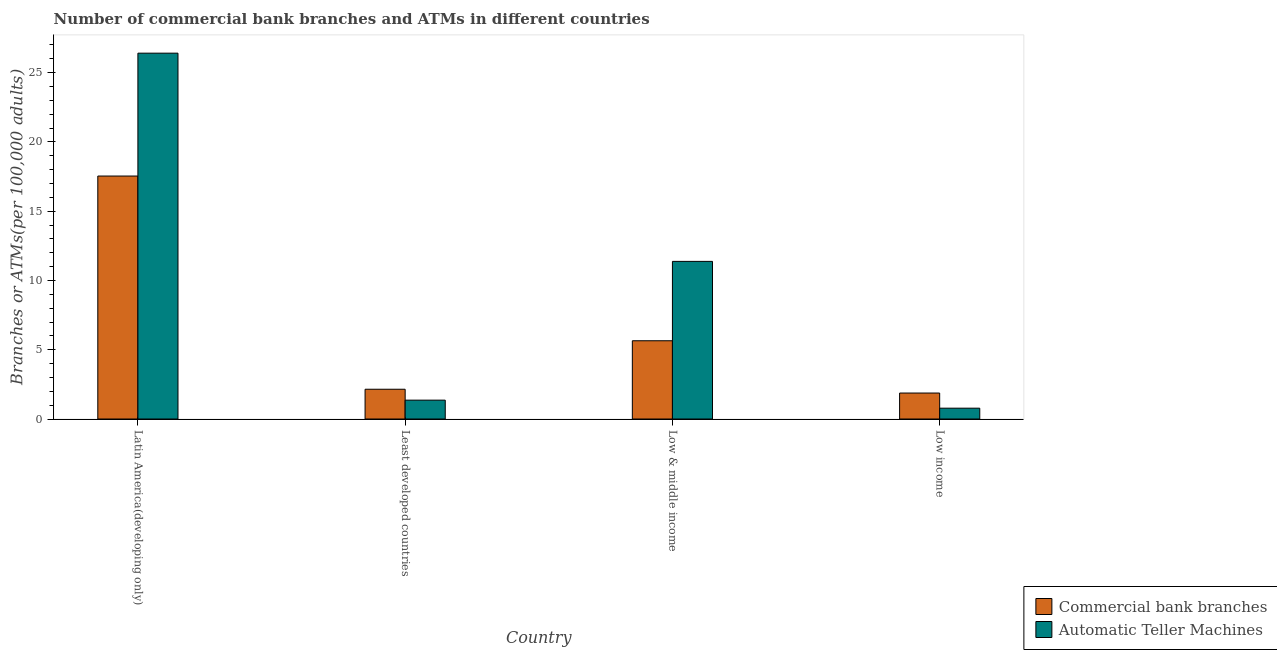How many groups of bars are there?
Offer a terse response. 4. Are the number of bars per tick equal to the number of legend labels?
Make the answer very short. Yes. How many bars are there on the 2nd tick from the left?
Offer a very short reply. 2. What is the label of the 4th group of bars from the left?
Keep it short and to the point. Low income. What is the number of commercal bank branches in Low & middle income?
Offer a very short reply. 5.65. Across all countries, what is the maximum number of atms?
Offer a terse response. 26.4. Across all countries, what is the minimum number of atms?
Keep it short and to the point. 0.78. In which country was the number of atms maximum?
Give a very brief answer. Latin America(developing only). What is the total number of commercal bank branches in the graph?
Your answer should be very brief. 27.21. What is the difference between the number of commercal bank branches in Latin America(developing only) and that in Low income?
Provide a short and direct response. 15.66. What is the difference between the number of atms in Low income and the number of commercal bank branches in Low & middle income?
Offer a very short reply. -4.87. What is the average number of atms per country?
Provide a succinct answer. 9.98. What is the difference between the number of atms and number of commercal bank branches in Latin America(developing only)?
Provide a short and direct response. 8.87. What is the ratio of the number of commercal bank branches in Latin America(developing only) to that in Low income?
Give a very brief answer. 9.35. What is the difference between the highest and the second highest number of atms?
Your answer should be compact. 15.03. What is the difference between the highest and the lowest number of commercal bank branches?
Offer a terse response. 15.66. In how many countries, is the number of atms greater than the average number of atms taken over all countries?
Your response must be concise. 2. Is the sum of the number of atms in Low & middle income and Low income greater than the maximum number of commercal bank branches across all countries?
Provide a short and direct response. No. What does the 2nd bar from the left in Low income represents?
Your response must be concise. Automatic Teller Machines. What does the 2nd bar from the right in Latin America(developing only) represents?
Your response must be concise. Commercial bank branches. Does the graph contain any zero values?
Provide a succinct answer. No. Does the graph contain grids?
Your answer should be very brief. No. Where does the legend appear in the graph?
Ensure brevity in your answer.  Bottom right. How are the legend labels stacked?
Ensure brevity in your answer.  Vertical. What is the title of the graph?
Offer a very short reply. Number of commercial bank branches and ATMs in different countries. Does "Girls" appear as one of the legend labels in the graph?
Make the answer very short. No. What is the label or title of the Y-axis?
Your answer should be compact. Branches or ATMs(per 100,0 adults). What is the Branches or ATMs(per 100,000 adults) of Commercial bank branches in Latin America(developing only)?
Your response must be concise. 17.53. What is the Branches or ATMs(per 100,000 adults) of Automatic Teller Machines in Latin America(developing only)?
Make the answer very short. 26.4. What is the Branches or ATMs(per 100,000 adults) of Commercial bank branches in Least developed countries?
Your answer should be compact. 2.15. What is the Branches or ATMs(per 100,000 adults) of Automatic Teller Machines in Least developed countries?
Your response must be concise. 1.36. What is the Branches or ATMs(per 100,000 adults) in Commercial bank branches in Low & middle income?
Provide a succinct answer. 5.65. What is the Branches or ATMs(per 100,000 adults) of Automatic Teller Machines in Low & middle income?
Offer a very short reply. 11.38. What is the Branches or ATMs(per 100,000 adults) in Commercial bank branches in Low income?
Your answer should be compact. 1.88. What is the Branches or ATMs(per 100,000 adults) of Automatic Teller Machines in Low income?
Your answer should be compact. 0.78. Across all countries, what is the maximum Branches or ATMs(per 100,000 adults) in Commercial bank branches?
Your answer should be compact. 17.53. Across all countries, what is the maximum Branches or ATMs(per 100,000 adults) of Automatic Teller Machines?
Offer a very short reply. 26.4. Across all countries, what is the minimum Branches or ATMs(per 100,000 adults) of Commercial bank branches?
Your answer should be compact. 1.88. Across all countries, what is the minimum Branches or ATMs(per 100,000 adults) of Automatic Teller Machines?
Your answer should be compact. 0.78. What is the total Branches or ATMs(per 100,000 adults) in Commercial bank branches in the graph?
Keep it short and to the point. 27.21. What is the total Branches or ATMs(per 100,000 adults) of Automatic Teller Machines in the graph?
Your answer should be very brief. 39.92. What is the difference between the Branches or ATMs(per 100,000 adults) of Commercial bank branches in Latin America(developing only) and that in Least developed countries?
Keep it short and to the point. 15.39. What is the difference between the Branches or ATMs(per 100,000 adults) of Automatic Teller Machines in Latin America(developing only) and that in Least developed countries?
Give a very brief answer. 25.04. What is the difference between the Branches or ATMs(per 100,000 adults) of Commercial bank branches in Latin America(developing only) and that in Low & middle income?
Make the answer very short. 11.89. What is the difference between the Branches or ATMs(per 100,000 adults) of Automatic Teller Machines in Latin America(developing only) and that in Low & middle income?
Give a very brief answer. 15.03. What is the difference between the Branches or ATMs(per 100,000 adults) of Commercial bank branches in Latin America(developing only) and that in Low income?
Provide a succinct answer. 15.66. What is the difference between the Branches or ATMs(per 100,000 adults) in Automatic Teller Machines in Latin America(developing only) and that in Low income?
Your answer should be very brief. 25.62. What is the difference between the Branches or ATMs(per 100,000 adults) of Commercial bank branches in Least developed countries and that in Low & middle income?
Offer a terse response. -3.5. What is the difference between the Branches or ATMs(per 100,000 adults) of Automatic Teller Machines in Least developed countries and that in Low & middle income?
Offer a very short reply. -10.01. What is the difference between the Branches or ATMs(per 100,000 adults) in Commercial bank branches in Least developed countries and that in Low income?
Your response must be concise. 0.27. What is the difference between the Branches or ATMs(per 100,000 adults) of Automatic Teller Machines in Least developed countries and that in Low income?
Your response must be concise. 0.58. What is the difference between the Branches or ATMs(per 100,000 adults) in Commercial bank branches in Low & middle income and that in Low income?
Offer a terse response. 3.77. What is the difference between the Branches or ATMs(per 100,000 adults) of Automatic Teller Machines in Low & middle income and that in Low income?
Your response must be concise. 10.59. What is the difference between the Branches or ATMs(per 100,000 adults) in Commercial bank branches in Latin America(developing only) and the Branches or ATMs(per 100,000 adults) in Automatic Teller Machines in Least developed countries?
Your answer should be very brief. 16.17. What is the difference between the Branches or ATMs(per 100,000 adults) of Commercial bank branches in Latin America(developing only) and the Branches or ATMs(per 100,000 adults) of Automatic Teller Machines in Low & middle income?
Offer a very short reply. 6.16. What is the difference between the Branches or ATMs(per 100,000 adults) of Commercial bank branches in Latin America(developing only) and the Branches or ATMs(per 100,000 adults) of Automatic Teller Machines in Low income?
Offer a very short reply. 16.75. What is the difference between the Branches or ATMs(per 100,000 adults) in Commercial bank branches in Least developed countries and the Branches or ATMs(per 100,000 adults) in Automatic Teller Machines in Low & middle income?
Provide a succinct answer. -9.23. What is the difference between the Branches or ATMs(per 100,000 adults) in Commercial bank branches in Least developed countries and the Branches or ATMs(per 100,000 adults) in Automatic Teller Machines in Low income?
Keep it short and to the point. 1.37. What is the difference between the Branches or ATMs(per 100,000 adults) in Commercial bank branches in Low & middle income and the Branches or ATMs(per 100,000 adults) in Automatic Teller Machines in Low income?
Provide a short and direct response. 4.87. What is the average Branches or ATMs(per 100,000 adults) of Commercial bank branches per country?
Make the answer very short. 6.8. What is the average Branches or ATMs(per 100,000 adults) of Automatic Teller Machines per country?
Offer a terse response. 9.98. What is the difference between the Branches or ATMs(per 100,000 adults) of Commercial bank branches and Branches or ATMs(per 100,000 adults) of Automatic Teller Machines in Latin America(developing only)?
Provide a short and direct response. -8.87. What is the difference between the Branches or ATMs(per 100,000 adults) of Commercial bank branches and Branches or ATMs(per 100,000 adults) of Automatic Teller Machines in Least developed countries?
Your answer should be very brief. 0.79. What is the difference between the Branches or ATMs(per 100,000 adults) of Commercial bank branches and Branches or ATMs(per 100,000 adults) of Automatic Teller Machines in Low & middle income?
Offer a terse response. -5.73. What is the difference between the Branches or ATMs(per 100,000 adults) of Commercial bank branches and Branches or ATMs(per 100,000 adults) of Automatic Teller Machines in Low income?
Offer a terse response. 1.09. What is the ratio of the Branches or ATMs(per 100,000 adults) in Commercial bank branches in Latin America(developing only) to that in Least developed countries?
Offer a very short reply. 8.16. What is the ratio of the Branches or ATMs(per 100,000 adults) in Automatic Teller Machines in Latin America(developing only) to that in Least developed countries?
Ensure brevity in your answer.  19.4. What is the ratio of the Branches or ATMs(per 100,000 adults) in Commercial bank branches in Latin America(developing only) to that in Low & middle income?
Your answer should be very brief. 3.1. What is the ratio of the Branches or ATMs(per 100,000 adults) of Automatic Teller Machines in Latin America(developing only) to that in Low & middle income?
Your response must be concise. 2.32. What is the ratio of the Branches or ATMs(per 100,000 adults) of Commercial bank branches in Latin America(developing only) to that in Low income?
Give a very brief answer. 9.35. What is the ratio of the Branches or ATMs(per 100,000 adults) of Automatic Teller Machines in Latin America(developing only) to that in Low income?
Your answer should be very brief. 33.74. What is the ratio of the Branches or ATMs(per 100,000 adults) of Commercial bank branches in Least developed countries to that in Low & middle income?
Make the answer very short. 0.38. What is the ratio of the Branches or ATMs(per 100,000 adults) of Automatic Teller Machines in Least developed countries to that in Low & middle income?
Offer a terse response. 0.12. What is the ratio of the Branches or ATMs(per 100,000 adults) of Commercial bank branches in Least developed countries to that in Low income?
Offer a very short reply. 1.15. What is the ratio of the Branches or ATMs(per 100,000 adults) in Automatic Teller Machines in Least developed countries to that in Low income?
Offer a very short reply. 1.74. What is the ratio of the Branches or ATMs(per 100,000 adults) of Commercial bank branches in Low & middle income to that in Low income?
Provide a short and direct response. 3.01. What is the ratio of the Branches or ATMs(per 100,000 adults) in Automatic Teller Machines in Low & middle income to that in Low income?
Offer a terse response. 14.54. What is the difference between the highest and the second highest Branches or ATMs(per 100,000 adults) in Commercial bank branches?
Make the answer very short. 11.89. What is the difference between the highest and the second highest Branches or ATMs(per 100,000 adults) in Automatic Teller Machines?
Give a very brief answer. 15.03. What is the difference between the highest and the lowest Branches or ATMs(per 100,000 adults) in Commercial bank branches?
Provide a succinct answer. 15.66. What is the difference between the highest and the lowest Branches or ATMs(per 100,000 adults) of Automatic Teller Machines?
Provide a short and direct response. 25.62. 